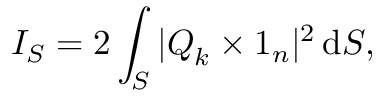<formula> <loc_0><loc_0><loc_500><loc_500>I _ { S } = 2 \int _ { S } | Q _ { k } \times 1 _ { n } | ^ { 2 } \, d S ,</formula> 